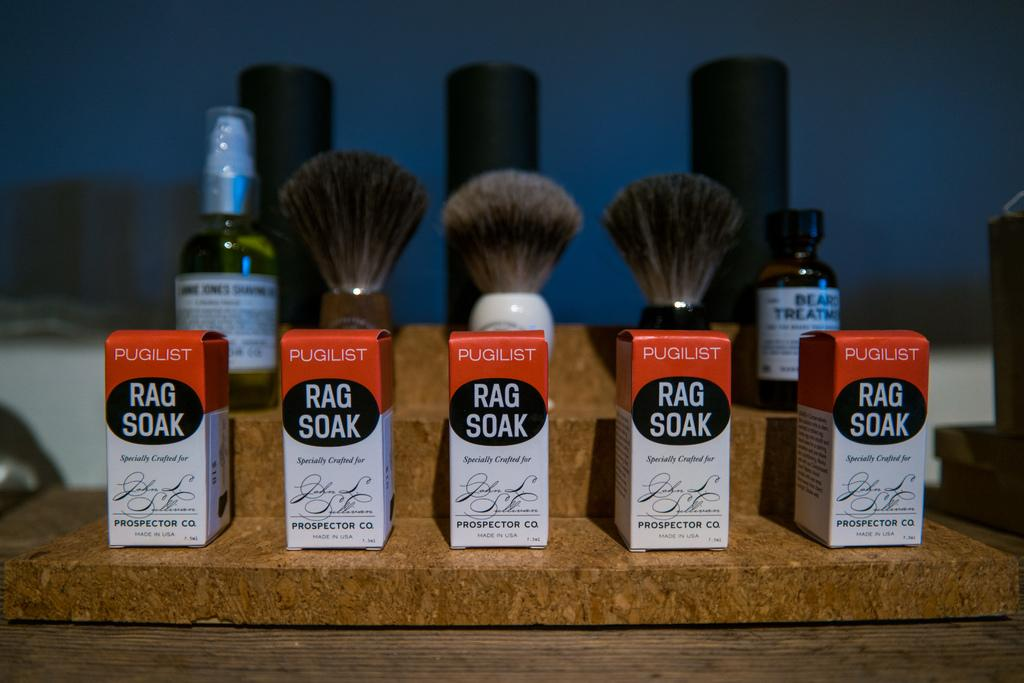<image>
Share a concise interpretation of the image provided. Five boxes of Pugilist Rag Soak in front of 3 shave brushes. 